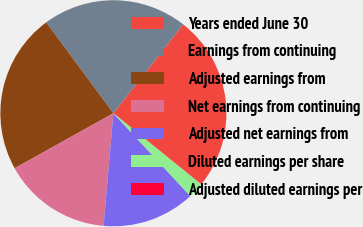<chart> <loc_0><loc_0><loc_500><loc_500><pie_chart><fcel>Years ended June 30<fcel>Earnings from continuing<fcel>Adjusted earnings from<fcel>Net earnings from continuing<fcel>Adjusted net earnings from<fcel>Diluted earnings per share<fcel>Adjusted diluted earnings per<nl><fcel>25.2%<fcel>20.73%<fcel>22.96%<fcel>15.53%<fcel>13.3%<fcel>2.26%<fcel>0.03%<nl></chart> 